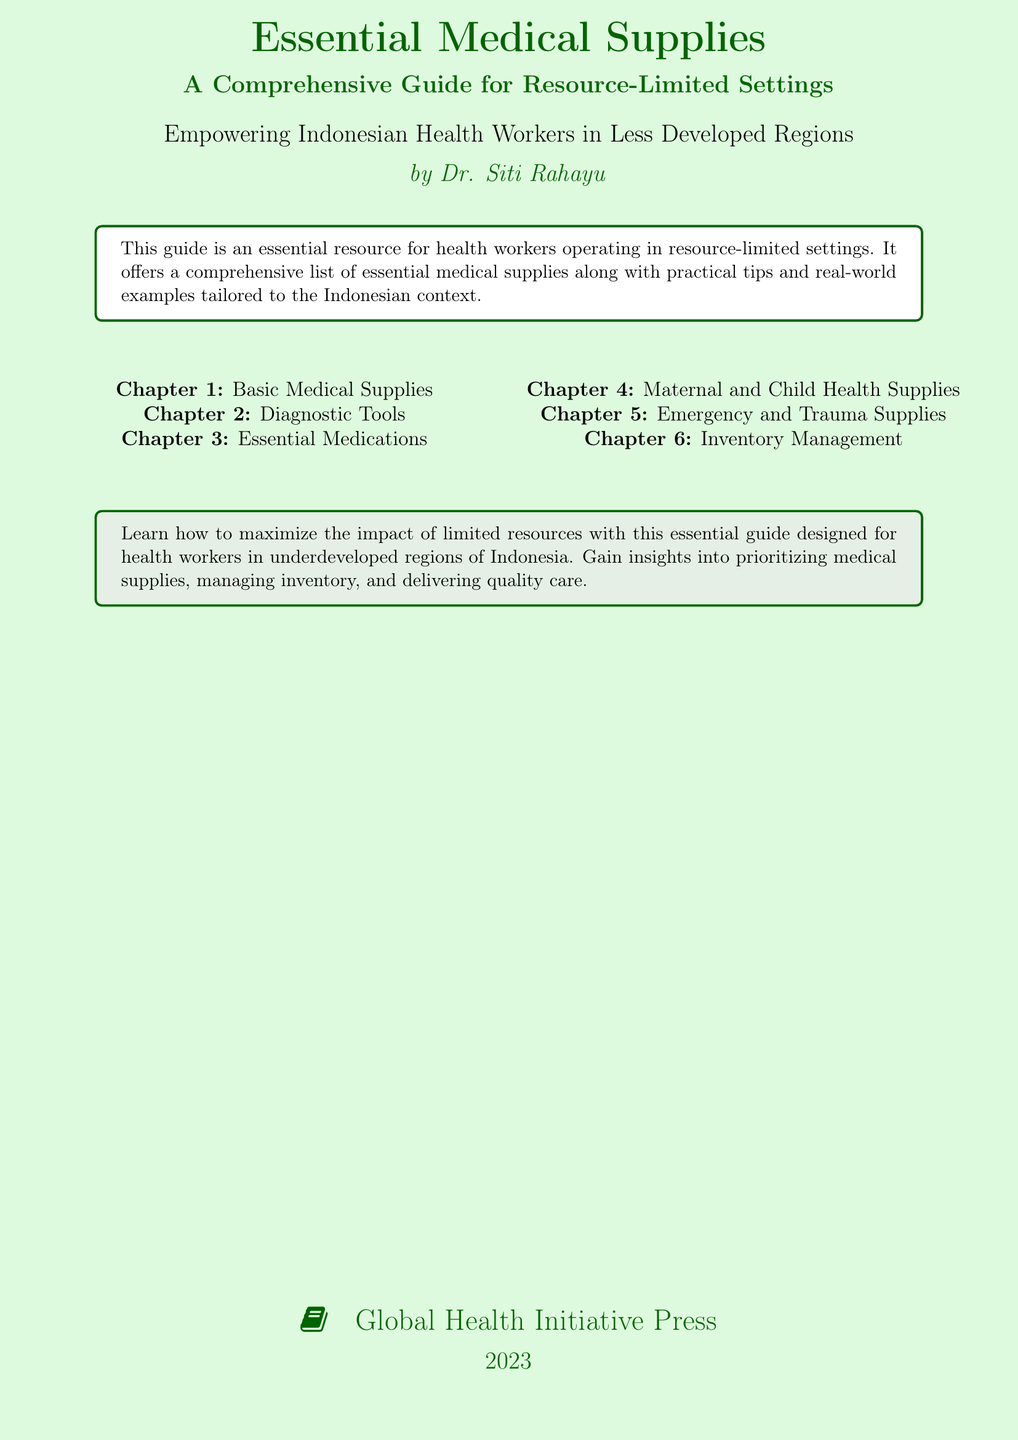What is the title of the book? The title of the book is explicitly stated on the cover.
Answer: Essential Medical Supplies Who is the author of the book? The author's name appears under the title on the cover.
Answer: Dr. Siti Rahayu What year was the book published? The publication year is mentioned at the bottom of the cover.
Answer: 2023 What type of guide is this book? The type of guide is indicated in the subtitle of the book.
Answer: A Comprehensive Guide for Resource-Limited Settings How many chapters are listed in the document? The number of chapters is counted from the provided list on the cover.
Answer: 6 What is the primary audience for this book? The primary audience is described in the text on the cover.
Answer: Indonesian Health Workers What is Chapter 4 focused on? Chapter 4’s focus is indicated in the list of chapters.
Answer: Maternal and Child Health Supplies What does the tcolorbox suggest about resource maximization? It suggests how to manage resources effectively based on the information in the tcolorbox.
Answer: Maximize the impact of limited resources What organization published this book? The publisher's information is at the bottom of the cover.
Answer: Global Health Initiative Press 